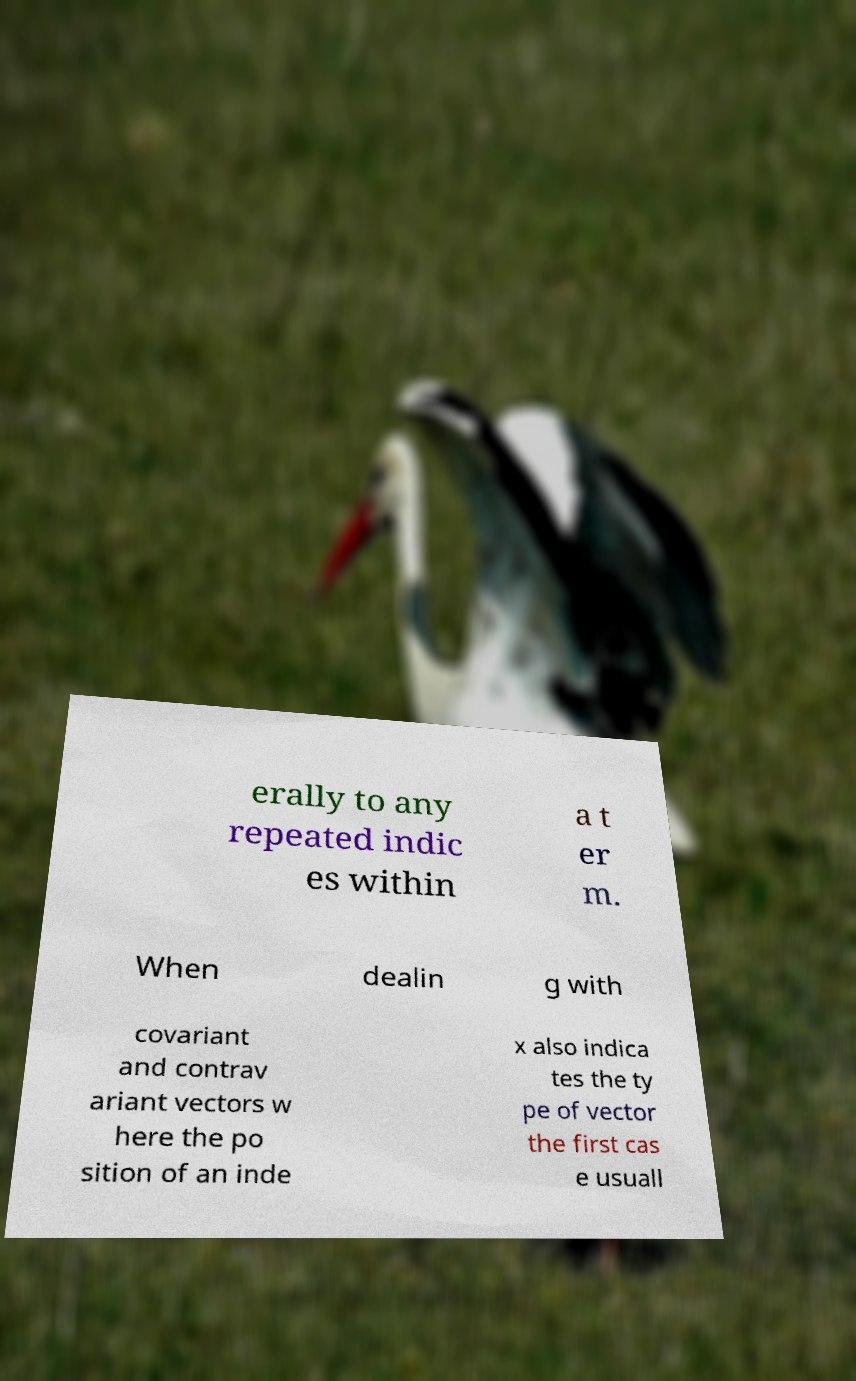Can you accurately transcribe the text from the provided image for me? erally to any repeated indic es within a t er m. When dealin g with covariant and contrav ariant vectors w here the po sition of an inde x also indica tes the ty pe of vector the first cas e usuall 